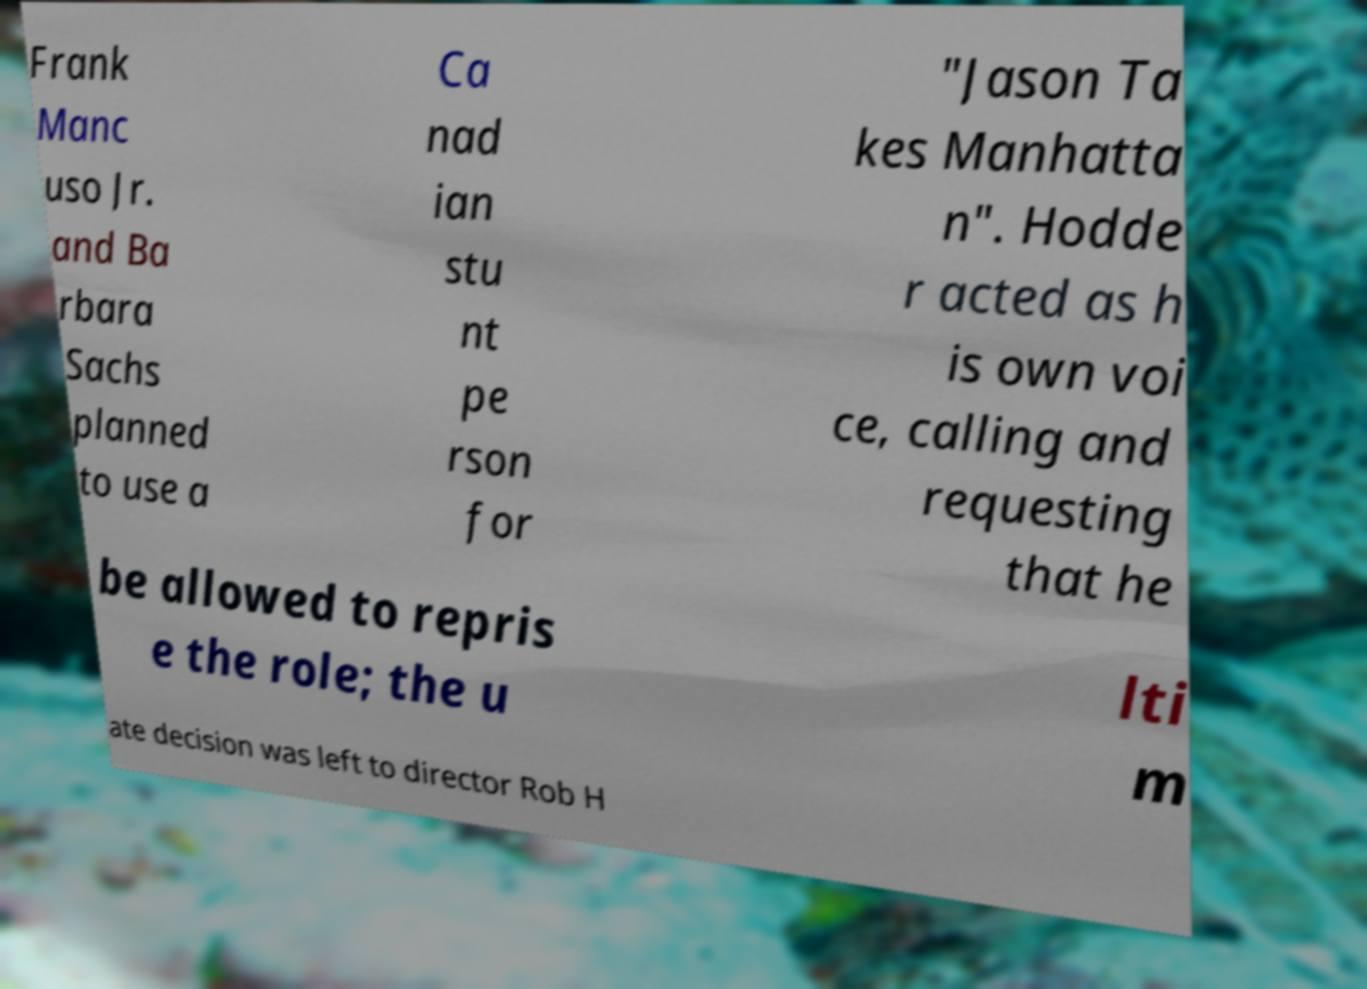Can you accurately transcribe the text from the provided image for me? Frank Manc uso Jr. and Ba rbara Sachs planned to use a Ca nad ian stu nt pe rson for "Jason Ta kes Manhatta n". Hodde r acted as h is own voi ce, calling and requesting that he be allowed to repris e the role; the u lti m ate decision was left to director Rob H 